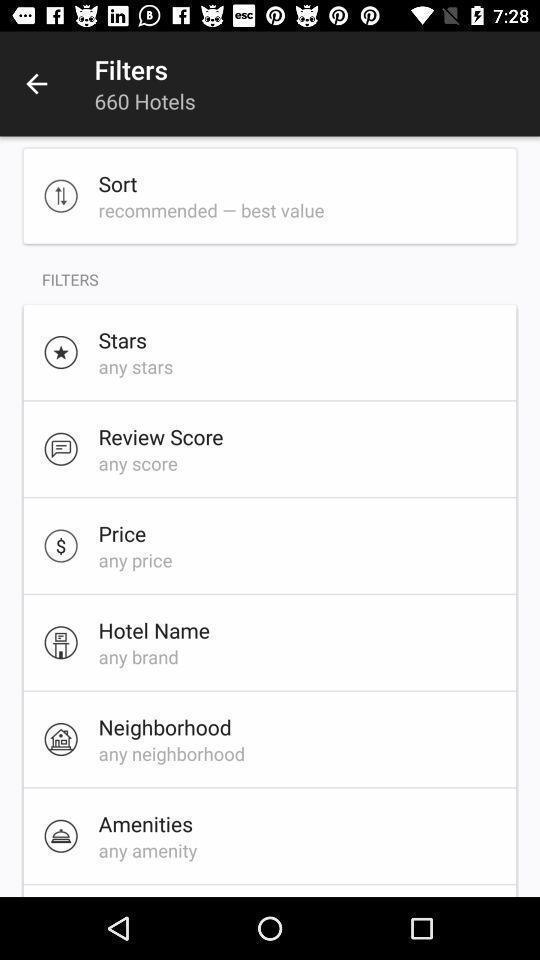Tell me about the visual elements in this screen capture. Various filters page displayed of a hotel bookings app. 